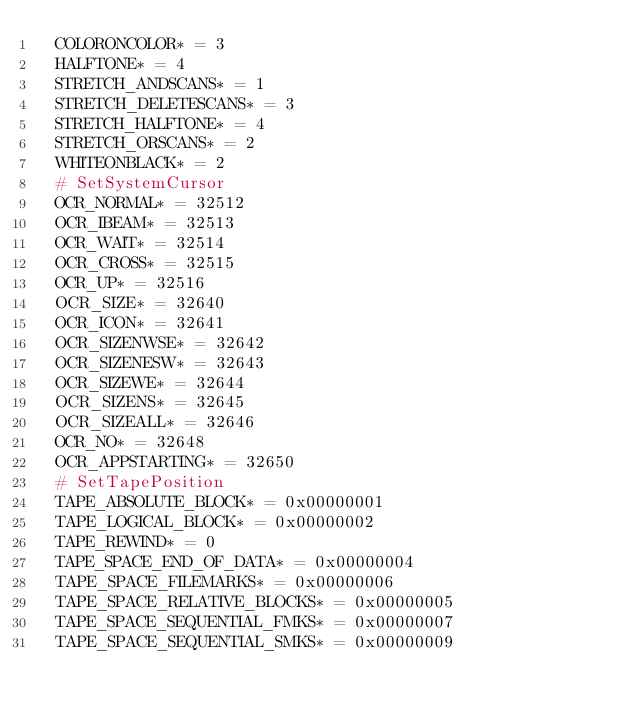Convert code to text. <code><loc_0><loc_0><loc_500><loc_500><_Nim_>  COLORONCOLOR* = 3
  HALFTONE* = 4
  STRETCH_ANDSCANS* = 1
  STRETCH_DELETESCANS* = 3
  STRETCH_HALFTONE* = 4
  STRETCH_ORSCANS* = 2
  WHITEONBLACK* = 2
  # SetSystemCursor
  OCR_NORMAL* = 32512
  OCR_IBEAM* = 32513
  OCR_WAIT* = 32514
  OCR_CROSS* = 32515
  OCR_UP* = 32516
  OCR_SIZE* = 32640
  OCR_ICON* = 32641
  OCR_SIZENWSE* = 32642
  OCR_SIZENESW* = 32643
  OCR_SIZEWE* = 32644
  OCR_SIZENS* = 32645
  OCR_SIZEALL* = 32646
  OCR_NO* = 32648
  OCR_APPSTARTING* = 32650
  # SetTapePosition
  TAPE_ABSOLUTE_BLOCK* = 0x00000001
  TAPE_LOGICAL_BLOCK* = 0x00000002
  TAPE_REWIND* = 0
  TAPE_SPACE_END_OF_DATA* = 0x00000004
  TAPE_SPACE_FILEMARKS* = 0x00000006
  TAPE_SPACE_RELATIVE_BLOCKS* = 0x00000005
  TAPE_SPACE_SEQUENTIAL_FMKS* = 0x00000007
  TAPE_SPACE_SEQUENTIAL_SMKS* = 0x00000009</code> 